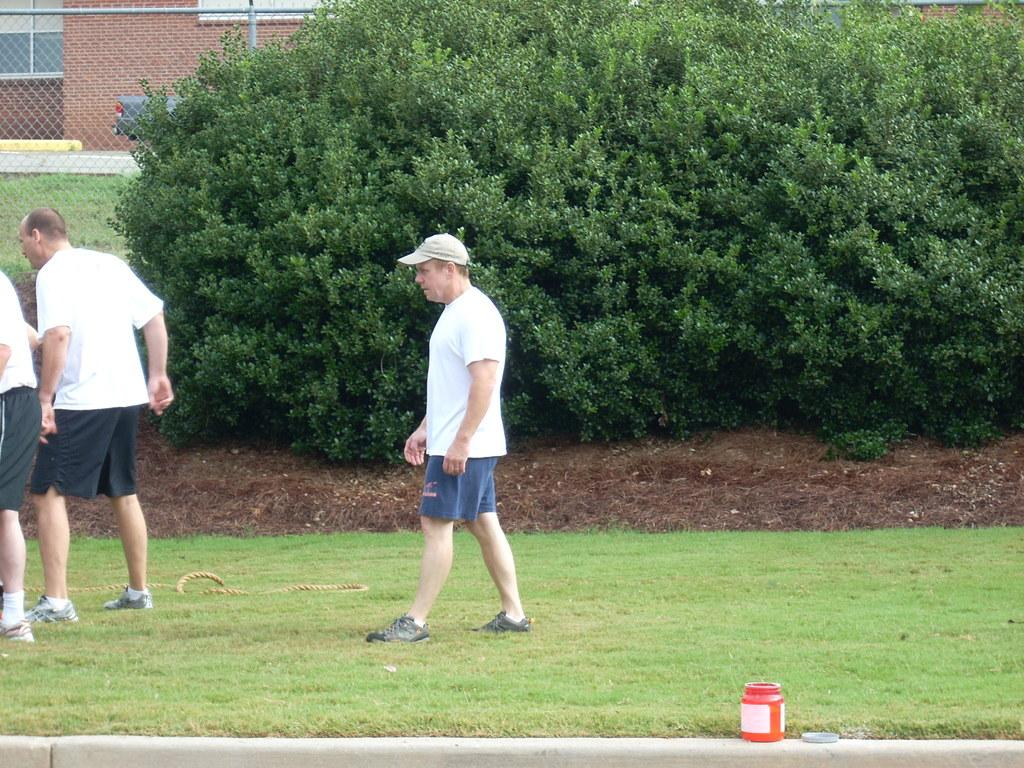Who is present in the image? There are men in the image. Where are the men located? The men are on a grassland. What can be seen in the background of the image? There is a building and a net boundary in the background of the image. What type of environment is depicted in the image? There is greenery in the image, suggesting a natural setting. What type of flower is being used as a sense of history in the image? There is no flower present in the image, nor is there any indication of a sense of history being conveyed through a flower. 